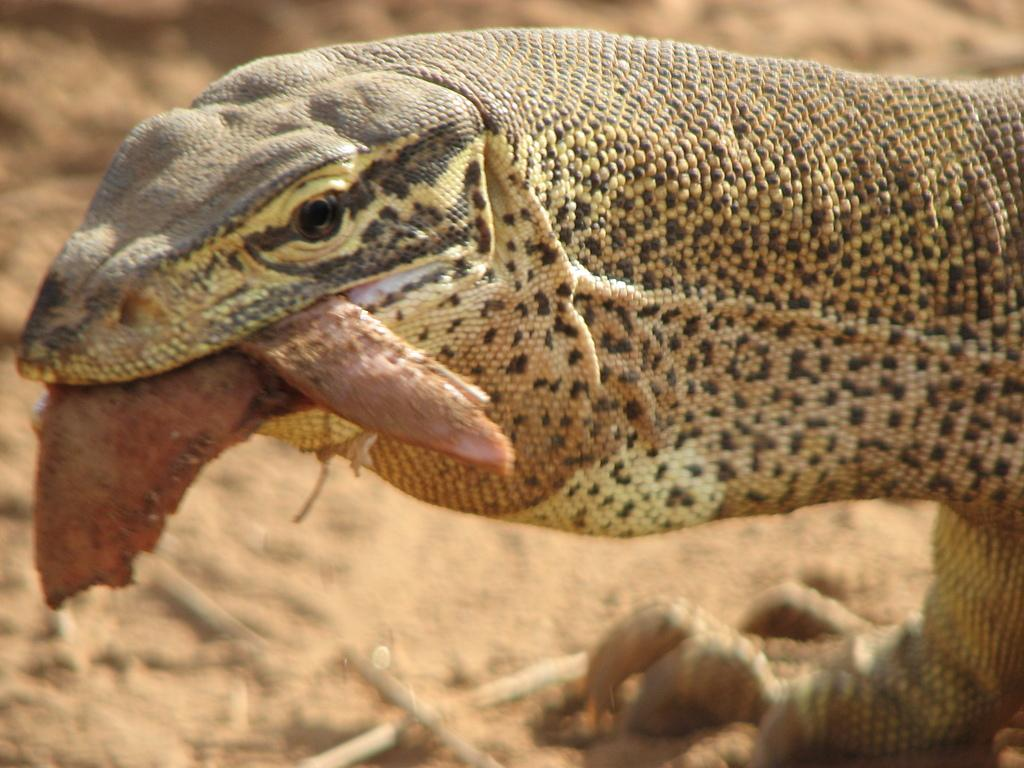What type of animal is in the image? There is a reptile in the image. Can you describe the color of the reptile? The reptile is brown and black in color. What type of legal advice can be obtained from the reptile in the image? There is no lawyer or legal advice present in the image; it features a reptile. What type of soda is being served with the reptile in the image? There is no soda present in the image; it features a reptile. 